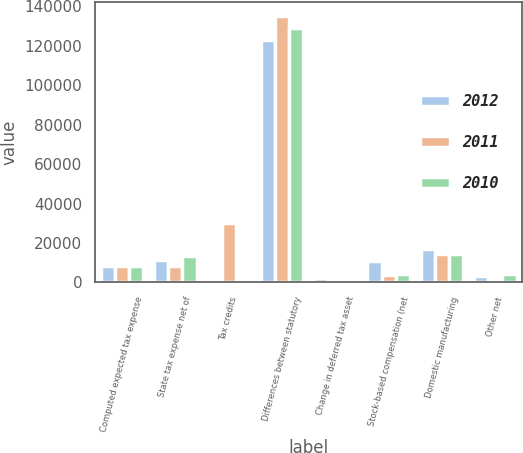Convert chart to OTSL. <chart><loc_0><loc_0><loc_500><loc_500><stacked_bar_chart><ecel><fcel>Computed expected tax expense<fcel>State tax expense net of<fcel>Tax credits<fcel>Differences between statutory<fcel>Change in deferred tax asset<fcel>Stock-based compensation (net<fcel>Domestic manufacturing<fcel>Other net<nl><fcel>2012<fcel>8436<fcel>11320<fcel>1226<fcel>122999<fcel>2144<fcel>10976<fcel>17010<fcel>3362<nl><fcel>2011<fcel>8436<fcel>8436<fcel>30283<fcel>135178<fcel>493<fcel>3983<fcel>14350<fcel>1041<nl><fcel>2010<fcel>8436<fcel>13444<fcel>1317<fcel>129063<fcel>1408<fcel>4181<fcel>14630<fcel>4098<nl></chart> 